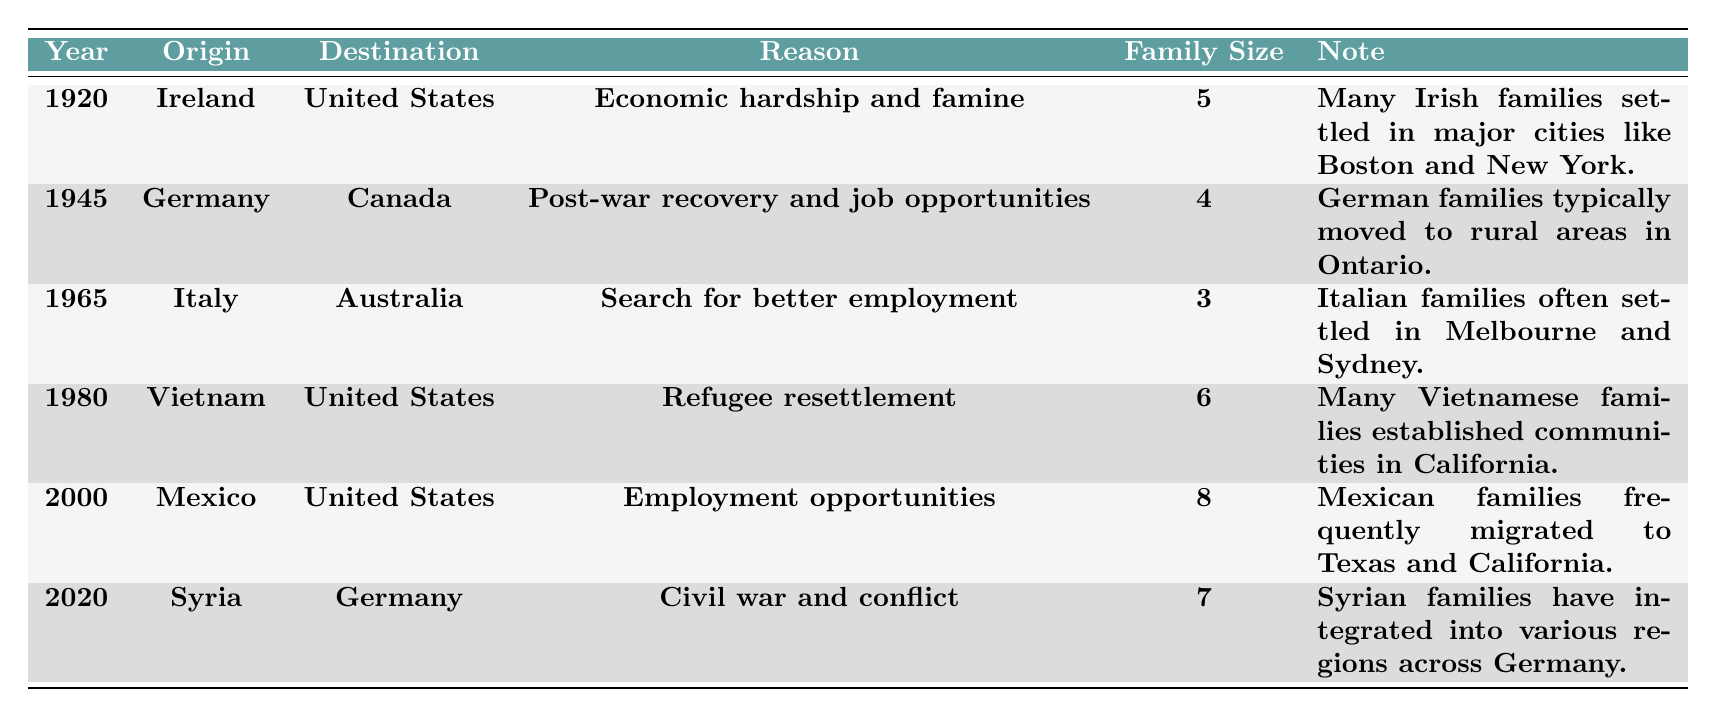What year did families migrate from Ireland to the United States? The table shows that families migrated from Ireland to the United States in the year 1920, as indicated in the "Year" column.
Answer: 1920 What was the family size of the German families migrating to Canada in 1945? Referring to the table, it specifies that the family size of German families migrating to Canada in 1945 was 4, as shown in the "Family Size" column.
Answer: 4 Did families from Vietnam migrate to the United States before or after the year 1980? The table indicates that Vietnamese families moved to the United States in 1980, confirming that they migrated to the United States in that year, not before.
Answer: After What were the two main reasons for migration listed in the table? Analyzing the "Reason" column in the table, the main reasons for migration are economic hardship and famine (Ireland), post-war recovery (Germany), search for better employment (Italy), refugee resettlement (Vietnam), employment opportunities (Mexico), and civil war and conflict (Syria). Thus, the two main reasons in general could be identified as economic and conflict-related.
Answer: Economic and conflict-related How many families migrated from Mexico to the United States compared to families from Italy to Australia? From the table, 8 families migrated from Mexico to the United States (2000) and 3 families migrated from Italy to Australia (1965). The difference is calculated as 8 - 3 = 5.
Answer: 5 more families What is the average family size of the migrations listed in the table? To find the average, sum all family sizes (5 + 4 + 3 + 6 + 8 + 7 = 33) and divide by the total number of migrations (6), giving 33/6 = 5.5.
Answer: 5.5 Which destination had the largest number of families migrating in a single year according to the table? The data shows that in 2000, 8 families migrated from Mexico to the United States, which is the highest number in a single year compared to the other entries.
Answer: United States What pattern can be observed in the destinations of families from Syria, Mexico, and Vietnam? Analyzing the table, all three families migrated to developed countries: Syrian families to Germany, Mexican families to the United States, and Vietnamese families also to the United States, which reflects a trend of seeking refuge or opportunities in more stable environments.
Answer: Developed countries Did any family migration reason involve factors related to employment? Yes, the migrations from Italy, Mexico, and Vietnam involved reasons related to employment. Specifically, Italian families searched for better employment, Mexican families sought employment opportunities, and Vietnamese families were part of refugee resettlement but also pursued better lives and work.
Answer: Yes What migration trend can be inferred about the years 1980 and 2000? In 1980, Vietnamese families migrated due to refugee resettlement, while in 2000, Mexican families moved seeking employment opportunities. This indicates a trend where different regions experienced migrations prompted by various socio-economic conditions in closer time frames.
Answer: Different socio-economic conditions 